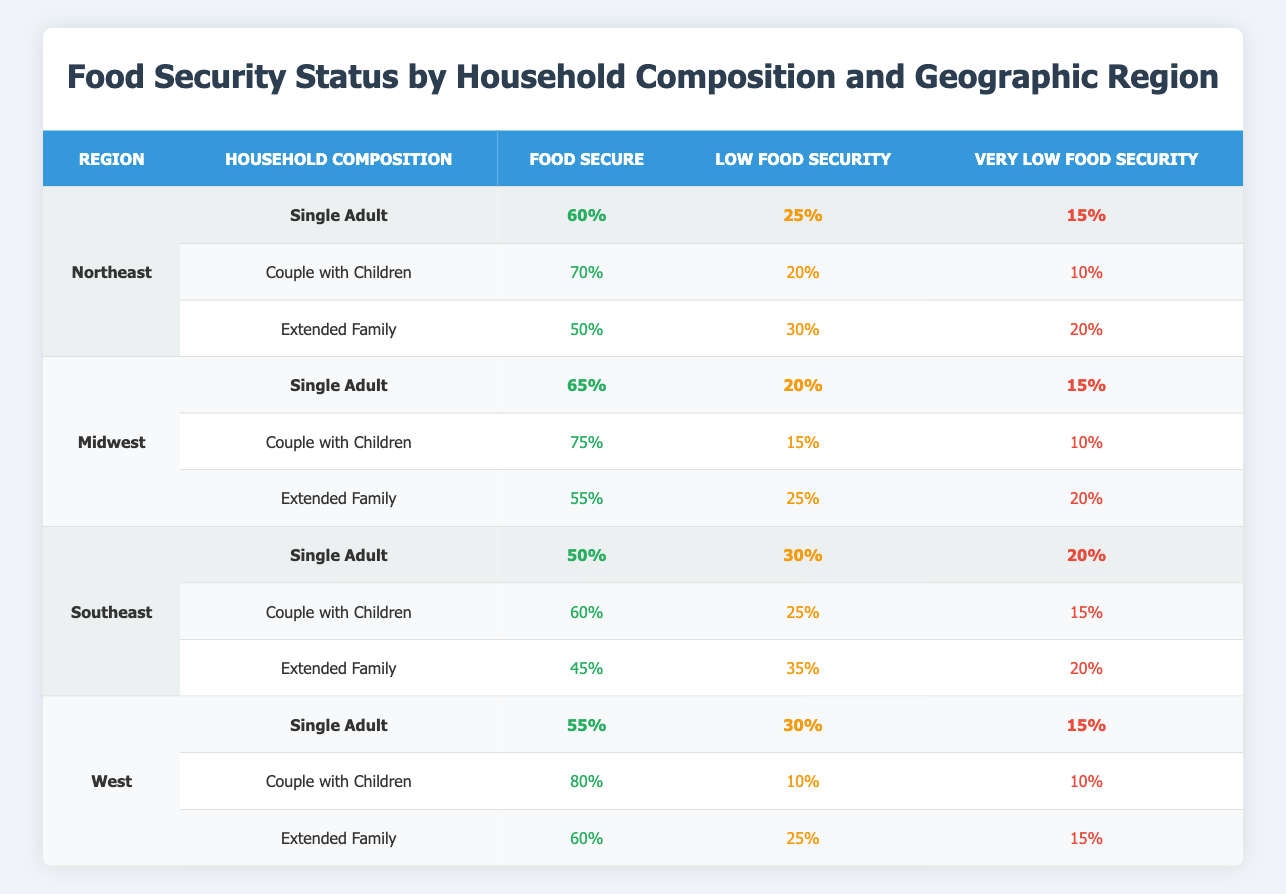What is the food security percentage for "Couple with Children" in the West region? According to the table, the food security percentage for "Couple with Children" in the West region is directly listed as 80%.
Answer: 80% Which household composition has the lowest percentage of food security in the Southeast region? The table shows that the "Extended Family" has the lowest food security percentage of 45% in the Southeast region.
Answer: Extended Family What is the difference in food security percentages between "Single Adult" in the Northeast and "Single Adult" in the Midwest? In the Northeast, the "Single Adult" food security percentage is 60%, while in the Midwest it is 65%. The difference is calculated as 65% - 60% = 5%.
Answer: 5% Is the "Very Low Food Security" percentage for "Extended Family" higher in the Southeast region compared to the Northeast region? In the Southeast, the "Very Low Food Security" percentage for "Extended Family" is 20%, while in the Northeast, it is 20% as well. Thus, the percentage is not higher in the Southeast.
Answer: No What is the average percentage of "Food Secure" for all household compositions in the Midwest? The "Food Secure" percentages for all household compositions in the Midwest are 65%, 75%, and 55%. The average is calculated by summing these (65 + 75 + 55 = 195) and then dividing by the number of compositions (3), which equals 195/3 = 65%.
Answer: 65% Which region shows the highest percentage of "Low Food Security" for "Couple with Children"? The table indicates that the West region shows the highest percentage of "Low Food Security" for "Couple with Children" at 10%.
Answer: West If the percentage of "Very Low Food Security" for "Single Adult" in the Northeast is considered, how does it compare to that in the West? In the Northeast, the percentage for "Single Adult" is 15%, while in the West it is also 15%. Since both percentages are the same, there is no difference.
Answer: They are the same What is the total percentage of food security status (Food Secure, Low Food Security, Very Low Food Security) for the "Couple with Children" in the Midwest? The percentages for "Couple with Children" in the Midwest are 75% (Food Secure), 15% (Low Food Security), and 10% (Very Low Food Security). The total is 75% + 15% + 10% = 100%.
Answer: 100% In the Northeast region, what is the trend in food security status from "Single Adult" to "Extended Family"? The data shows a decrease in food security from "Single Adult" (60%) to "Extended Family" (50%), with "Low Food Security" increasing from 25% to 30% and "Very Low Food Security" increasing from 15% to 20%. The trend indicates worsening food security.
Answer: Worsening food security 